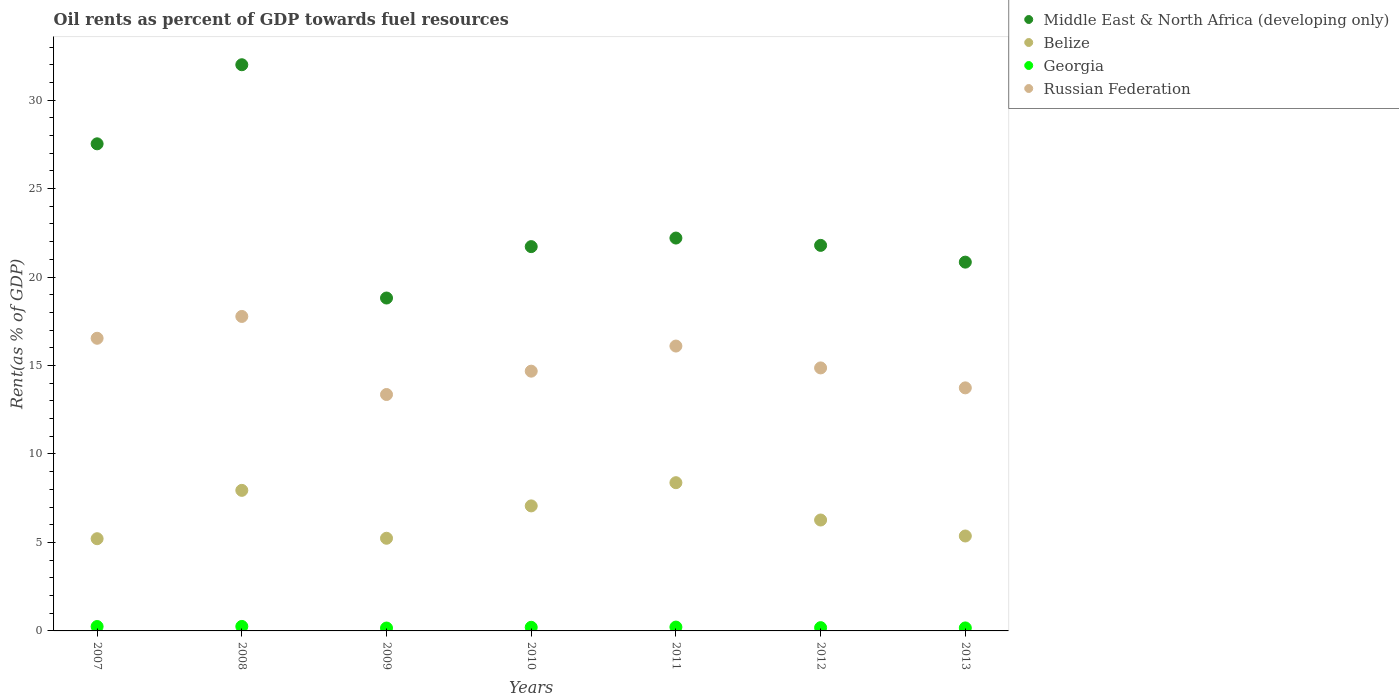How many different coloured dotlines are there?
Your answer should be compact. 4. What is the oil rent in Belize in 2008?
Your answer should be compact. 7.94. Across all years, what is the maximum oil rent in Russian Federation?
Keep it short and to the point. 17.77. Across all years, what is the minimum oil rent in Georgia?
Provide a short and direct response. 0.16. In which year was the oil rent in Middle East & North Africa (developing only) minimum?
Your answer should be compact. 2009. What is the total oil rent in Middle East & North Africa (developing only) in the graph?
Offer a very short reply. 164.91. What is the difference between the oil rent in Belize in 2007 and that in 2009?
Ensure brevity in your answer.  -0.03. What is the difference between the oil rent in Middle East & North Africa (developing only) in 2013 and the oil rent in Russian Federation in 2012?
Your response must be concise. 5.98. What is the average oil rent in Middle East & North Africa (developing only) per year?
Your answer should be very brief. 23.56. In the year 2013, what is the difference between the oil rent in Belize and oil rent in Russian Federation?
Provide a succinct answer. -8.37. What is the ratio of the oil rent in Georgia in 2009 to that in 2011?
Your answer should be compact. 0.75. Is the oil rent in Belize in 2010 less than that in 2012?
Give a very brief answer. No. What is the difference between the highest and the second highest oil rent in Belize?
Provide a succinct answer. 0.43. What is the difference between the highest and the lowest oil rent in Belize?
Your response must be concise. 3.17. Is it the case that in every year, the sum of the oil rent in Georgia and oil rent in Belize  is greater than the sum of oil rent in Middle East & North Africa (developing only) and oil rent in Russian Federation?
Your response must be concise. No. Is it the case that in every year, the sum of the oil rent in Middle East & North Africa (developing only) and oil rent in Russian Federation  is greater than the oil rent in Georgia?
Give a very brief answer. Yes. Is the oil rent in Belize strictly greater than the oil rent in Georgia over the years?
Offer a very short reply. Yes. How many dotlines are there?
Your answer should be compact. 4. How many years are there in the graph?
Keep it short and to the point. 7. What is the difference between two consecutive major ticks on the Y-axis?
Provide a short and direct response. 5. Are the values on the major ticks of Y-axis written in scientific E-notation?
Your answer should be very brief. No. Does the graph contain any zero values?
Provide a succinct answer. No. Does the graph contain grids?
Your answer should be very brief. No. Where does the legend appear in the graph?
Give a very brief answer. Top right. How many legend labels are there?
Give a very brief answer. 4. How are the legend labels stacked?
Your response must be concise. Vertical. What is the title of the graph?
Ensure brevity in your answer.  Oil rents as percent of GDP towards fuel resources. Does "United Kingdom" appear as one of the legend labels in the graph?
Give a very brief answer. No. What is the label or title of the Y-axis?
Keep it short and to the point. Rent(as % of GDP). What is the Rent(as % of GDP) in Middle East & North Africa (developing only) in 2007?
Make the answer very short. 27.53. What is the Rent(as % of GDP) in Belize in 2007?
Your answer should be very brief. 5.21. What is the Rent(as % of GDP) in Georgia in 2007?
Give a very brief answer. 0.25. What is the Rent(as % of GDP) of Russian Federation in 2007?
Provide a short and direct response. 16.54. What is the Rent(as % of GDP) of Middle East & North Africa (developing only) in 2008?
Keep it short and to the point. 32. What is the Rent(as % of GDP) in Belize in 2008?
Offer a terse response. 7.94. What is the Rent(as % of GDP) in Georgia in 2008?
Keep it short and to the point. 0.25. What is the Rent(as % of GDP) in Russian Federation in 2008?
Keep it short and to the point. 17.77. What is the Rent(as % of GDP) in Middle East & North Africa (developing only) in 2009?
Give a very brief answer. 18.82. What is the Rent(as % of GDP) of Belize in 2009?
Offer a terse response. 5.24. What is the Rent(as % of GDP) in Georgia in 2009?
Your response must be concise. 0.16. What is the Rent(as % of GDP) of Russian Federation in 2009?
Keep it short and to the point. 13.36. What is the Rent(as % of GDP) of Middle East & North Africa (developing only) in 2010?
Give a very brief answer. 21.72. What is the Rent(as % of GDP) in Belize in 2010?
Your answer should be very brief. 7.07. What is the Rent(as % of GDP) in Georgia in 2010?
Your answer should be compact. 0.2. What is the Rent(as % of GDP) in Russian Federation in 2010?
Your answer should be very brief. 14.68. What is the Rent(as % of GDP) of Middle East & North Africa (developing only) in 2011?
Ensure brevity in your answer.  22.21. What is the Rent(as % of GDP) in Belize in 2011?
Offer a very short reply. 8.38. What is the Rent(as % of GDP) in Georgia in 2011?
Your response must be concise. 0.22. What is the Rent(as % of GDP) of Russian Federation in 2011?
Provide a short and direct response. 16.1. What is the Rent(as % of GDP) of Middle East & North Africa (developing only) in 2012?
Offer a very short reply. 21.79. What is the Rent(as % of GDP) of Belize in 2012?
Offer a terse response. 6.27. What is the Rent(as % of GDP) of Georgia in 2012?
Your answer should be very brief. 0.18. What is the Rent(as % of GDP) in Russian Federation in 2012?
Offer a very short reply. 14.87. What is the Rent(as % of GDP) of Middle East & North Africa (developing only) in 2013?
Your answer should be compact. 20.84. What is the Rent(as % of GDP) in Belize in 2013?
Your answer should be compact. 5.37. What is the Rent(as % of GDP) of Georgia in 2013?
Offer a very short reply. 0.17. What is the Rent(as % of GDP) in Russian Federation in 2013?
Keep it short and to the point. 13.74. Across all years, what is the maximum Rent(as % of GDP) in Middle East & North Africa (developing only)?
Offer a very short reply. 32. Across all years, what is the maximum Rent(as % of GDP) in Belize?
Your response must be concise. 8.38. Across all years, what is the maximum Rent(as % of GDP) of Georgia?
Offer a terse response. 0.25. Across all years, what is the maximum Rent(as % of GDP) in Russian Federation?
Your answer should be compact. 17.77. Across all years, what is the minimum Rent(as % of GDP) in Middle East & North Africa (developing only)?
Your answer should be compact. 18.82. Across all years, what is the minimum Rent(as % of GDP) in Belize?
Give a very brief answer. 5.21. Across all years, what is the minimum Rent(as % of GDP) in Georgia?
Provide a succinct answer. 0.16. Across all years, what is the minimum Rent(as % of GDP) of Russian Federation?
Provide a succinct answer. 13.36. What is the total Rent(as % of GDP) in Middle East & North Africa (developing only) in the graph?
Offer a very short reply. 164.91. What is the total Rent(as % of GDP) in Belize in the graph?
Offer a terse response. 45.47. What is the total Rent(as % of GDP) in Georgia in the graph?
Make the answer very short. 1.44. What is the total Rent(as % of GDP) of Russian Federation in the graph?
Ensure brevity in your answer.  107.06. What is the difference between the Rent(as % of GDP) in Middle East & North Africa (developing only) in 2007 and that in 2008?
Provide a short and direct response. -4.47. What is the difference between the Rent(as % of GDP) in Belize in 2007 and that in 2008?
Your answer should be compact. -2.73. What is the difference between the Rent(as % of GDP) of Georgia in 2007 and that in 2008?
Provide a short and direct response. -0. What is the difference between the Rent(as % of GDP) in Russian Federation in 2007 and that in 2008?
Give a very brief answer. -1.23. What is the difference between the Rent(as % of GDP) of Middle East & North Africa (developing only) in 2007 and that in 2009?
Your answer should be very brief. 8.72. What is the difference between the Rent(as % of GDP) in Belize in 2007 and that in 2009?
Your answer should be very brief. -0.03. What is the difference between the Rent(as % of GDP) in Georgia in 2007 and that in 2009?
Offer a terse response. 0.09. What is the difference between the Rent(as % of GDP) of Russian Federation in 2007 and that in 2009?
Keep it short and to the point. 3.18. What is the difference between the Rent(as % of GDP) in Middle East & North Africa (developing only) in 2007 and that in 2010?
Your response must be concise. 5.81. What is the difference between the Rent(as % of GDP) of Belize in 2007 and that in 2010?
Ensure brevity in your answer.  -1.85. What is the difference between the Rent(as % of GDP) in Georgia in 2007 and that in 2010?
Provide a succinct answer. 0.04. What is the difference between the Rent(as % of GDP) in Russian Federation in 2007 and that in 2010?
Your answer should be very brief. 1.86. What is the difference between the Rent(as % of GDP) of Middle East & North Africa (developing only) in 2007 and that in 2011?
Keep it short and to the point. 5.33. What is the difference between the Rent(as % of GDP) in Belize in 2007 and that in 2011?
Provide a succinct answer. -3.17. What is the difference between the Rent(as % of GDP) in Georgia in 2007 and that in 2011?
Provide a succinct answer. 0.03. What is the difference between the Rent(as % of GDP) of Russian Federation in 2007 and that in 2011?
Offer a very short reply. 0.44. What is the difference between the Rent(as % of GDP) of Middle East & North Africa (developing only) in 2007 and that in 2012?
Offer a terse response. 5.74. What is the difference between the Rent(as % of GDP) in Belize in 2007 and that in 2012?
Your answer should be compact. -1.06. What is the difference between the Rent(as % of GDP) in Georgia in 2007 and that in 2012?
Give a very brief answer. 0.06. What is the difference between the Rent(as % of GDP) of Russian Federation in 2007 and that in 2012?
Offer a terse response. 1.68. What is the difference between the Rent(as % of GDP) of Middle East & North Africa (developing only) in 2007 and that in 2013?
Your answer should be compact. 6.69. What is the difference between the Rent(as % of GDP) in Belize in 2007 and that in 2013?
Provide a short and direct response. -0.15. What is the difference between the Rent(as % of GDP) in Georgia in 2007 and that in 2013?
Make the answer very short. 0.08. What is the difference between the Rent(as % of GDP) in Russian Federation in 2007 and that in 2013?
Offer a very short reply. 2.8. What is the difference between the Rent(as % of GDP) in Middle East & North Africa (developing only) in 2008 and that in 2009?
Your response must be concise. 13.19. What is the difference between the Rent(as % of GDP) of Belize in 2008 and that in 2009?
Your answer should be very brief. 2.71. What is the difference between the Rent(as % of GDP) in Georgia in 2008 and that in 2009?
Keep it short and to the point. 0.09. What is the difference between the Rent(as % of GDP) of Russian Federation in 2008 and that in 2009?
Keep it short and to the point. 4.41. What is the difference between the Rent(as % of GDP) in Middle East & North Africa (developing only) in 2008 and that in 2010?
Your response must be concise. 10.28. What is the difference between the Rent(as % of GDP) in Belize in 2008 and that in 2010?
Your answer should be very brief. 0.88. What is the difference between the Rent(as % of GDP) of Georgia in 2008 and that in 2010?
Provide a succinct answer. 0.05. What is the difference between the Rent(as % of GDP) of Russian Federation in 2008 and that in 2010?
Provide a short and direct response. 3.09. What is the difference between the Rent(as % of GDP) of Middle East & North Africa (developing only) in 2008 and that in 2011?
Provide a succinct answer. 9.8. What is the difference between the Rent(as % of GDP) of Belize in 2008 and that in 2011?
Make the answer very short. -0.43. What is the difference between the Rent(as % of GDP) of Georgia in 2008 and that in 2011?
Offer a terse response. 0.04. What is the difference between the Rent(as % of GDP) of Russian Federation in 2008 and that in 2011?
Offer a terse response. 1.67. What is the difference between the Rent(as % of GDP) in Middle East & North Africa (developing only) in 2008 and that in 2012?
Provide a succinct answer. 10.21. What is the difference between the Rent(as % of GDP) of Belize in 2008 and that in 2012?
Give a very brief answer. 1.68. What is the difference between the Rent(as % of GDP) of Georgia in 2008 and that in 2012?
Provide a succinct answer. 0.07. What is the difference between the Rent(as % of GDP) of Russian Federation in 2008 and that in 2012?
Offer a very short reply. 2.91. What is the difference between the Rent(as % of GDP) of Middle East & North Africa (developing only) in 2008 and that in 2013?
Offer a terse response. 11.16. What is the difference between the Rent(as % of GDP) of Belize in 2008 and that in 2013?
Your response must be concise. 2.58. What is the difference between the Rent(as % of GDP) of Georgia in 2008 and that in 2013?
Provide a short and direct response. 0.08. What is the difference between the Rent(as % of GDP) of Russian Federation in 2008 and that in 2013?
Provide a succinct answer. 4.04. What is the difference between the Rent(as % of GDP) in Middle East & North Africa (developing only) in 2009 and that in 2010?
Your response must be concise. -2.91. What is the difference between the Rent(as % of GDP) of Belize in 2009 and that in 2010?
Your answer should be very brief. -1.83. What is the difference between the Rent(as % of GDP) of Georgia in 2009 and that in 2010?
Offer a very short reply. -0.04. What is the difference between the Rent(as % of GDP) of Russian Federation in 2009 and that in 2010?
Give a very brief answer. -1.32. What is the difference between the Rent(as % of GDP) of Middle East & North Africa (developing only) in 2009 and that in 2011?
Give a very brief answer. -3.39. What is the difference between the Rent(as % of GDP) in Belize in 2009 and that in 2011?
Provide a succinct answer. -3.14. What is the difference between the Rent(as % of GDP) of Georgia in 2009 and that in 2011?
Keep it short and to the point. -0.05. What is the difference between the Rent(as % of GDP) in Russian Federation in 2009 and that in 2011?
Your answer should be very brief. -2.74. What is the difference between the Rent(as % of GDP) in Middle East & North Africa (developing only) in 2009 and that in 2012?
Give a very brief answer. -2.98. What is the difference between the Rent(as % of GDP) in Belize in 2009 and that in 2012?
Your response must be concise. -1.03. What is the difference between the Rent(as % of GDP) of Georgia in 2009 and that in 2012?
Your answer should be compact. -0.02. What is the difference between the Rent(as % of GDP) of Russian Federation in 2009 and that in 2012?
Make the answer very short. -1.5. What is the difference between the Rent(as % of GDP) in Middle East & North Africa (developing only) in 2009 and that in 2013?
Provide a short and direct response. -2.03. What is the difference between the Rent(as % of GDP) in Belize in 2009 and that in 2013?
Keep it short and to the point. -0.13. What is the difference between the Rent(as % of GDP) of Georgia in 2009 and that in 2013?
Give a very brief answer. -0.01. What is the difference between the Rent(as % of GDP) of Russian Federation in 2009 and that in 2013?
Provide a short and direct response. -0.38. What is the difference between the Rent(as % of GDP) of Middle East & North Africa (developing only) in 2010 and that in 2011?
Offer a terse response. -0.48. What is the difference between the Rent(as % of GDP) of Belize in 2010 and that in 2011?
Your answer should be very brief. -1.31. What is the difference between the Rent(as % of GDP) in Georgia in 2010 and that in 2011?
Your response must be concise. -0.01. What is the difference between the Rent(as % of GDP) of Russian Federation in 2010 and that in 2011?
Your answer should be very brief. -1.42. What is the difference between the Rent(as % of GDP) in Middle East & North Africa (developing only) in 2010 and that in 2012?
Provide a short and direct response. -0.07. What is the difference between the Rent(as % of GDP) in Belize in 2010 and that in 2012?
Keep it short and to the point. 0.8. What is the difference between the Rent(as % of GDP) of Georgia in 2010 and that in 2012?
Provide a short and direct response. 0.02. What is the difference between the Rent(as % of GDP) of Russian Federation in 2010 and that in 2012?
Your response must be concise. -0.18. What is the difference between the Rent(as % of GDP) in Middle East & North Africa (developing only) in 2010 and that in 2013?
Provide a short and direct response. 0.88. What is the difference between the Rent(as % of GDP) in Belize in 2010 and that in 2013?
Give a very brief answer. 1.7. What is the difference between the Rent(as % of GDP) of Georgia in 2010 and that in 2013?
Keep it short and to the point. 0.03. What is the difference between the Rent(as % of GDP) of Russian Federation in 2010 and that in 2013?
Provide a succinct answer. 0.94. What is the difference between the Rent(as % of GDP) in Middle East & North Africa (developing only) in 2011 and that in 2012?
Offer a very short reply. 0.41. What is the difference between the Rent(as % of GDP) of Belize in 2011 and that in 2012?
Make the answer very short. 2.11. What is the difference between the Rent(as % of GDP) in Georgia in 2011 and that in 2012?
Provide a short and direct response. 0.03. What is the difference between the Rent(as % of GDP) of Russian Federation in 2011 and that in 2012?
Your answer should be very brief. 1.24. What is the difference between the Rent(as % of GDP) in Middle East & North Africa (developing only) in 2011 and that in 2013?
Offer a very short reply. 1.36. What is the difference between the Rent(as % of GDP) in Belize in 2011 and that in 2013?
Your answer should be compact. 3.01. What is the difference between the Rent(as % of GDP) in Georgia in 2011 and that in 2013?
Offer a very short reply. 0.05. What is the difference between the Rent(as % of GDP) in Russian Federation in 2011 and that in 2013?
Your answer should be very brief. 2.36. What is the difference between the Rent(as % of GDP) of Middle East & North Africa (developing only) in 2012 and that in 2013?
Offer a terse response. 0.95. What is the difference between the Rent(as % of GDP) in Belize in 2012 and that in 2013?
Your response must be concise. 0.9. What is the difference between the Rent(as % of GDP) of Georgia in 2012 and that in 2013?
Keep it short and to the point. 0.02. What is the difference between the Rent(as % of GDP) in Russian Federation in 2012 and that in 2013?
Give a very brief answer. 1.13. What is the difference between the Rent(as % of GDP) of Middle East & North Africa (developing only) in 2007 and the Rent(as % of GDP) of Belize in 2008?
Offer a very short reply. 19.59. What is the difference between the Rent(as % of GDP) in Middle East & North Africa (developing only) in 2007 and the Rent(as % of GDP) in Georgia in 2008?
Make the answer very short. 27.28. What is the difference between the Rent(as % of GDP) in Middle East & North Africa (developing only) in 2007 and the Rent(as % of GDP) in Russian Federation in 2008?
Your answer should be compact. 9.76. What is the difference between the Rent(as % of GDP) in Belize in 2007 and the Rent(as % of GDP) in Georgia in 2008?
Provide a short and direct response. 4.96. What is the difference between the Rent(as % of GDP) of Belize in 2007 and the Rent(as % of GDP) of Russian Federation in 2008?
Your answer should be compact. -12.56. What is the difference between the Rent(as % of GDP) in Georgia in 2007 and the Rent(as % of GDP) in Russian Federation in 2008?
Your answer should be very brief. -17.53. What is the difference between the Rent(as % of GDP) in Middle East & North Africa (developing only) in 2007 and the Rent(as % of GDP) in Belize in 2009?
Your response must be concise. 22.29. What is the difference between the Rent(as % of GDP) in Middle East & North Africa (developing only) in 2007 and the Rent(as % of GDP) in Georgia in 2009?
Keep it short and to the point. 27.37. What is the difference between the Rent(as % of GDP) in Middle East & North Africa (developing only) in 2007 and the Rent(as % of GDP) in Russian Federation in 2009?
Ensure brevity in your answer.  14.17. What is the difference between the Rent(as % of GDP) in Belize in 2007 and the Rent(as % of GDP) in Georgia in 2009?
Your answer should be compact. 5.05. What is the difference between the Rent(as % of GDP) in Belize in 2007 and the Rent(as % of GDP) in Russian Federation in 2009?
Your answer should be compact. -8.15. What is the difference between the Rent(as % of GDP) of Georgia in 2007 and the Rent(as % of GDP) of Russian Federation in 2009?
Your answer should be very brief. -13.11. What is the difference between the Rent(as % of GDP) of Middle East & North Africa (developing only) in 2007 and the Rent(as % of GDP) of Belize in 2010?
Offer a very short reply. 20.46. What is the difference between the Rent(as % of GDP) in Middle East & North Africa (developing only) in 2007 and the Rent(as % of GDP) in Georgia in 2010?
Your answer should be very brief. 27.33. What is the difference between the Rent(as % of GDP) of Middle East & North Africa (developing only) in 2007 and the Rent(as % of GDP) of Russian Federation in 2010?
Your response must be concise. 12.85. What is the difference between the Rent(as % of GDP) of Belize in 2007 and the Rent(as % of GDP) of Georgia in 2010?
Your answer should be very brief. 5.01. What is the difference between the Rent(as % of GDP) in Belize in 2007 and the Rent(as % of GDP) in Russian Federation in 2010?
Offer a terse response. -9.47. What is the difference between the Rent(as % of GDP) of Georgia in 2007 and the Rent(as % of GDP) of Russian Federation in 2010?
Provide a succinct answer. -14.43. What is the difference between the Rent(as % of GDP) of Middle East & North Africa (developing only) in 2007 and the Rent(as % of GDP) of Belize in 2011?
Your response must be concise. 19.15. What is the difference between the Rent(as % of GDP) in Middle East & North Africa (developing only) in 2007 and the Rent(as % of GDP) in Georgia in 2011?
Offer a terse response. 27.31. What is the difference between the Rent(as % of GDP) in Middle East & North Africa (developing only) in 2007 and the Rent(as % of GDP) in Russian Federation in 2011?
Offer a terse response. 11.43. What is the difference between the Rent(as % of GDP) of Belize in 2007 and the Rent(as % of GDP) of Georgia in 2011?
Provide a short and direct response. 5. What is the difference between the Rent(as % of GDP) in Belize in 2007 and the Rent(as % of GDP) in Russian Federation in 2011?
Offer a terse response. -10.89. What is the difference between the Rent(as % of GDP) of Georgia in 2007 and the Rent(as % of GDP) of Russian Federation in 2011?
Your response must be concise. -15.85. What is the difference between the Rent(as % of GDP) of Middle East & North Africa (developing only) in 2007 and the Rent(as % of GDP) of Belize in 2012?
Your answer should be compact. 21.26. What is the difference between the Rent(as % of GDP) in Middle East & North Africa (developing only) in 2007 and the Rent(as % of GDP) in Georgia in 2012?
Your answer should be very brief. 27.35. What is the difference between the Rent(as % of GDP) in Middle East & North Africa (developing only) in 2007 and the Rent(as % of GDP) in Russian Federation in 2012?
Make the answer very short. 12.67. What is the difference between the Rent(as % of GDP) of Belize in 2007 and the Rent(as % of GDP) of Georgia in 2012?
Offer a very short reply. 5.03. What is the difference between the Rent(as % of GDP) in Belize in 2007 and the Rent(as % of GDP) in Russian Federation in 2012?
Give a very brief answer. -9.65. What is the difference between the Rent(as % of GDP) of Georgia in 2007 and the Rent(as % of GDP) of Russian Federation in 2012?
Provide a succinct answer. -14.62. What is the difference between the Rent(as % of GDP) of Middle East & North Africa (developing only) in 2007 and the Rent(as % of GDP) of Belize in 2013?
Make the answer very short. 22.17. What is the difference between the Rent(as % of GDP) of Middle East & North Africa (developing only) in 2007 and the Rent(as % of GDP) of Georgia in 2013?
Offer a terse response. 27.36. What is the difference between the Rent(as % of GDP) in Middle East & North Africa (developing only) in 2007 and the Rent(as % of GDP) in Russian Federation in 2013?
Your response must be concise. 13.79. What is the difference between the Rent(as % of GDP) in Belize in 2007 and the Rent(as % of GDP) in Georgia in 2013?
Keep it short and to the point. 5.04. What is the difference between the Rent(as % of GDP) in Belize in 2007 and the Rent(as % of GDP) in Russian Federation in 2013?
Give a very brief answer. -8.53. What is the difference between the Rent(as % of GDP) in Georgia in 2007 and the Rent(as % of GDP) in Russian Federation in 2013?
Your answer should be very brief. -13.49. What is the difference between the Rent(as % of GDP) of Middle East & North Africa (developing only) in 2008 and the Rent(as % of GDP) of Belize in 2009?
Ensure brevity in your answer.  26.76. What is the difference between the Rent(as % of GDP) in Middle East & North Africa (developing only) in 2008 and the Rent(as % of GDP) in Georgia in 2009?
Your answer should be compact. 31.84. What is the difference between the Rent(as % of GDP) in Middle East & North Africa (developing only) in 2008 and the Rent(as % of GDP) in Russian Federation in 2009?
Your response must be concise. 18.64. What is the difference between the Rent(as % of GDP) of Belize in 2008 and the Rent(as % of GDP) of Georgia in 2009?
Provide a short and direct response. 7.78. What is the difference between the Rent(as % of GDP) in Belize in 2008 and the Rent(as % of GDP) in Russian Federation in 2009?
Make the answer very short. -5.42. What is the difference between the Rent(as % of GDP) of Georgia in 2008 and the Rent(as % of GDP) of Russian Federation in 2009?
Your answer should be compact. -13.11. What is the difference between the Rent(as % of GDP) of Middle East & North Africa (developing only) in 2008 and the Rent(as % of GDP) of Belize in 2010?
Provide a short and direct response. 24.93. What is the difference between the Rent(as % of GDP) in Middle East & North Africa (developing only) in 2008 and the Rent(as % of GDP) in Georgia in 2010?
Ensure brevity in your answer.  31.8. What is the difference between the Rent(as % of GDP) in Middle East & North Africa (developing only) in 2008 and the Rent(as % of GDP) in Russian Federation in 2010?
Your response must be concise. 17.32. What is the difference between the Rent(as % of GDP) of Belize in 2008 and the Rent(as % of GDP) of Georgia in 2010?
Offer a very short reply. 7.74. What is the difference between the Rent(as % of GDP) of Belize in 2008 and the Rent(as % of GDP) of Russian Federation in 2010?
Make the answer very short. -6.74. What is the difference between the Rent(as % of GDP) in Georgia in 2008 and the Rent(as % of GDP) in Russian Federation in 2010?
Make the answer very short. -14.43. What is the difference between the Rent(as % of GDP) in Middle East & North Africa (developing only) in 2008 and the Rent(as % of GDP) in Belize in 2011?
Your answer should be compact. 23.62. What is the difference between the Rent(as % of GDP) of Middle East & North Africa (developing only) in 2008 and the Rent(as % of GDP) of Georgia in 2011?
Ensure brevity in your answer.  31.78. What is the difference between the Rent(as % of GDP) of Middle East & North Africa (developing only) in 2008 and the Rent(as % of GDP) of Russian Federation in 2011?
Your response must be concise. 15.9. What is the difference between the Rent(as % of GDP) in Belize in 2008 and the Rent(as % of GDP) in Georgia in 2011?
Ensure brevity in your answer.  7.73. What is the difference between the Rent(as % of GDP) of Belize in 2008 and the Rent(as % of GDP) of Russian Federation in 2011?
Ensure brevity in your answer.  -8.16. What is the difference between the Rent(as % of GDP) of Georgia in 2008 and the Rent(as % of GDP) of Russian Federation in 2011?
Keep it short and to the point. -15.85. What is the difference between the Rent(as % of GDP) in Middle East & North Africa (developing only) in 2008 and the Rent(as % of GDP) in Belize in 2012?
Your answer should be compact. 25.73. What is the difference between the Rent(as % of GDP) in Middle East & North Africa (developing only) in 2008 and the Rent(as % of GDP) in Georgia in 2012?
Keep it short and to the point. 31.82. What is the difference between the Rent(as % of GDP) of Middle East & North Africa (developing only) in 2008 and the Rent(as % of GDP) of Russian Federation in 2012?
Make the answer very short. 17.14. What is the difference between the Rent(as % of GDP) of Belize in 2008 and the Rent(as % of GDP) of Georgia in 2012?
Offer a very short reply. 7.76. What is the difference between the Rent(as % of GDP) in Belize in 2008 and the Rent(as % of GDP) in Russian Federation in 2012?
Provide a short and direct response. -6.92. What is the difference between the Rent(as % of GDP) of Georgia in 2008 and the Rent(as % of GDP) of Russian Federation in 2012?
Your answer should be very brief. -14.61. What is the difference between the Rent(as % of GDP) in Middle East & North Africa (developing only) in 2008 and the Rent(as % of GDP) in Belize in 2013?
Your answer should be compact. 26.64. What is the difference between the Rent(as % of GDP) in Middle East & North Africa (developing only) in 2008 and the Rent(as % of GDP) in Georgia in 2013?
Make the answer very short. 31.83. What is the difference between the Rent(as % of GDP) in Middle East & North Africa (developing only) in 2008 and the Rent(as % of GDP) in Russian Federation in 2013?
Give a very brief answer. 18.26. What is the difference between the Rent(as % of GDP) of Belize in 2008 and the Rent(as % of GDP) of Georgia in 2013?
Give a very brief answer. 7.78. What is the difference between the Rent(as % of GDP) in Belize in 2008 and the Rent(as % of GDP) in Russian Federation in 2013?
Keep it short and to the point. -5.79. What is the difference between the Rent(as % of GDP) of Georgia in 2008 and the Rent(as % of GDP) of Russian Federation in 2013?
Ensure brevity in your answer.  -13.48. What is the difference between the Rent(as % of GDP) of Middle East & North Africa (developing only) in 2009 and the Rent(as % of GDP) of Belize in 2010?
Make the answer very short. 11.75. What is the difference between the Rent(as % of GDP) in Middle East & North Africa (developing only) in 2009 and the Rent(as % of GDP) in Georgia in 2010?
Provide a succinct answer. 18.61. What is the difference between the Rent(as % of GDP) of Middle East & North Africa (developing only) in 2009 and the Rent(as % of GDP) of Russian Federation in 2010?
Your response must be concise. 4.13. What is the difference between the Rent(as % of GDP) in Belize in 2009 and the Rent(as % of GDP) in Georgia in 2010?
Your answer should be very brief. 5.03. What is the difference between the Rent(as % of GDP) of Belize in 2009 and the Rent(as % of GDP) of Russian Federation in 2010?
Ensure brevity in your answer.  -9.44. What is the difference between the Rent(as % of GDP) in Georgia in 2009 and the Rent(as % of GDP) in Russian Federation in 2010?
Your answer should be very brief. -14.52. What is the difference between the Rent(as % of GDP) of Middle East & North Africa (developing only) in 2009 and the Rent(as % of GDP) of Belize in 2011?
Give a very brief answer. 10.44. What is the difference between the Rent(as % of GDP) in Middle East & North Africa (developing only) in 2009 and the Rent(as % of GDP) in Georgia in 2011?
Provide a succinct answer. 18.6. What is the difference between the Rent(as % of GDP) of Middle East & North Africa (developing only) in 2009 and the Rent(as % of GDP) of Russian Federation in 2011?
Give a very brief answer. 2.71. What is the difference between the Rent(as % of GDP) in Belize in 2009 and the Rent(as % of GDP) in Georgia in 2011?
Provide a succinct answer. 5.02. What is the difference between the Rent(as % of GDP) of Belize in 2009 and the Rent(as % of GDP) of Russian Federation in 2011?
Keep it short and to the point. -10.86. What is the difference between the Rent(as % of GDP) of Georgia in 2009 and the Rent(as % of GDP) of Russian Federation in 2011?
Keep it short and to the point. -15.94. What is the difference between the Rent(as % of GDP) in Middle East & North Africa (developing only) in 2009 and the Rent(as % of GDP) in Belize in 2012?
Your response must be concise. 12.55. What is the difference between the Rent(as % of GDP) in Middle East & North Africa (developing only) in 2009 and the Rent(as % of GDP) in Georgia in 2012?
Provide a short and direct response. 18.63. What is the difference between the Rent(as % of GDP) in Middle East & North Africa (developing only) in 2009 and the Rent(as % of GDP) in Russian Federation in 2012?
Provide a short and direct response. 3.95. What is the difference between the Rent(as % of GDP) of Belize in 2009 and the Rent(as % of GDP) of Georgia in 2012?
Make the answer very short. 5.05. What is the difference between the Rent(as % of GDP) in Belize in 2009 and the Rent(as % of GDP) in Russian Federation in 2012?
Your answer should be very brief. -9.63. What is the difference between the Rent(as % of GDP) in Georgia in 2009 and the Rent(as % of GDP) in Russian Federation in 2012?
Your answer should be very brief. -14.7. What is the difference between the Rent(as % of GDP) in Middle East & North Africa (developing only) in 2009 and the Rent(as % of GDP) in Belize in 2013?
Ensure brevity in your answer.  13.45. What is the difference between the Rent(as % of GDP) of Middle East & North Africa (developing only) in 2009 and the Rent(as % of GDP) of Georgia in 2013?
Provide a short and direct response. 18.65. What is the difference between the Rent(as % of GDP) in Middle East & North Africa (developing only) in 2009 and the Rent(as % of GDP) in Russian Federation in 2013?
Your answer should be very brief. 5.08. What is the difference between the Rent(as % of GDP) in Belize in 2009 and the Rent(as % of GDP) in Georgia in 2013?
Make the answer very short. 5.07. What is the difference between the Rent(as % of GDP) of Belize in 2009 and the Rent(as % of GDP) of Russian Federation in 2013?
Offer a very short reply. -8.5. What is the difference between the Rent(as % of GDP) of Georgia in 2009 and the Rent(as % of GDP) of Russian Federation in 2013?
Ensure brevity in your answer.  -13.57. What is the difference between the Rent(as % of GDP) of Middle East & North Africa (developing only) in 2010 and the Rent(as % of GDP) of Belize in 2011?
Provide a short and direct response. 13.34. What is the difference between the Rent(as % of GDP) in Middle East & North Africa (developing only) in 2010 and the Rent(as % of GDP) in Georgia in 2011?
Ensure brevity in your answer.  21.5. What is the difference between the Rent(as % of GDP) in Middle East & North Africa (developing only) in 2010 and the Rent(as % of GDP) in Russian Federation in 2011?
Keep it short and to the point. 5.62. What is the difference between the Rent(as % of GDP) in Belize in 2010 and the Rent(as % of GDP) in Georgia in 2011?
Ensure brevity in your answer.  6.85. What is the difference between the Rent(as % of GDP) in Belize in 2010 and the Rent(as % of GDP) in Russian Federation in 2011?
Give a very brief answer. -9.03. What is the difference between the Rent(as % of GDP) in Georgia in 2010 and the Rent(as % of GDP) in Russian Federation in 2011?
Your answer should be very brief. -15.9. What is the difference between the Rent(as % of GDP) in Middle East & North Africa (developing only) in 2010 and the Rent(as % of GDP) in Belize in 2012?
Make the answer very short. 15.45. What is the difference between the Rent(as % of GDP) in Middle East & North Africa (developing only) in 2010 and the Rent(as % of GDP) in Georgia in 2012?
Your answer should be very brief. 21.54. What is the difference between the Rent(as % of GDP) in Middle East & North Africa (developing only) in 2010 and the Rent(as % of GDP) in Russian Federation in 2012?
Your answer should be compact. 6.86. What is the difference between the Rent(as % of GDP) in Belize in 2010 and the Rent(as % of GDP) in Georgia in 2012?
Your answer should be very brief. 6.88. What is the difference between the Rent(as % of GDP) of Belize in 2010 and the Rent(as % of GDP) of Russian Federation in 2012?
Provide a short and direct response. -7.8. What is the difference between the Rent(as % of GDP) of Georgia in 2010 and the Rent(as % of GDP) of Russian Federation in 2012?
Provide a short and direct response. -14.66. What is the difference between the Rent(as % of GDP) in Middle East & North Africa (developing only) in 2010 and the Rent(as % of GDP) in Belize in 2013?
Provide a short and direct response. 16.36. What is the difference between the Rent(as % of GDP) of Middle East & North Africa (developing only) in 2010 and the Rent(as % of GDP) of Georgia in 2013?
Your answer should be compact. 21.55. What is the difference between the Rent(as % of GDP) of Middle East & North Africa (developing only) in 2010 and the Rent(as % of GDP) of Russian Federation in 2013?
Ensure brevity in your answer.  7.98. What is the difference between the Rent(as % of GDP) of Belize in 2010 and the Rent(as % of GDP) of Georgia in 2013?
Provide a succinct answer. 6.9. What is the difference between the Rent(as % of GDP) of Belize in 2010 and the Rent(as % of GDP) of Russian Federation in 2013?
Provide a succinct answer. -6.67. What is the difference between the Rent(as % of GDP) in Georgia in 2010 and the Rent(as % of GDP) in Russian Federation in 2013?
Your answer should be very brief. -13.53. What is the difference between the Rent(as % of GDP) in Middle East & North Africa (developing only) in 2011 and the Rent(as % of GDP) in Belize in 2012?
Keep it short and to the point. 15.94. What is the difference between the Rent(as % of GDP) of Middle East & North Africa (developing only) in 2011 and the Rent(as % of GDP) of Georgia in 2012?
Keep it short and to the point. 22.02. What is the difference between the Rent(as % of GDP) in Middle East & North Africa (developing only) in 2011 and the Rent(as % of GDP) in Russian Federation in 2012?
Ensure brevity in your answer.  7.34. What is the difference between the Rent(as % of GDP) in Belize in 2011 and the Rent(as % of GDP) in Georgia in 2012?
Give a very brief answer. 8.19. What is the difference between the Rent(as % of GDP) of Belize in 2011 and the Rent(as % of GDP) of Russian Federation in 2012?
Offer a very short reply. -6.49. What is the difference between the Rent(as % of GDP) in Georgia in 2011 and the Rent(as % of GDP) in Russian Federation in 2012?
Your response must be concise. -14.65. What is the difference between the Rent(as % of GDP) of Middle East & North Africa (developing only) in 2011 and the Rent(as % of GDP) of Belize in 2013?
Your response must be concise. 16.84. What is the difference between the Rent(as % of GDP) in Middle East & North Africa (developing only) in 2011 and the Rent(as % of GDP) in Georgia in 2013?
Your answer should be very brief. 22.04. What is the difference between the Rent(as % of GDP) in Middle East & North Africa (developing only) in 2011 and the Rent(as % of GDP) in Russian Federation in 2013?
Provide a short and direct response. 8.47. What is the difference between the Rent(as % of GDP) of Belize in 2011 and the Rent(as % of GDP) of Georgia in 2013?
Ensure brevity in your answer.  8.21. What is the difference between the Rent(as % of GDP) of Belize in 2011 and the Rent(as % of GDP) of Russian Federation in 2013?
Give a very brief answer. -5.36. What is the difference between the Rent(as % of GDP) of Georgia in 2011 and the Rent(as % of GDP) of Russian Federation in 2013?
Give a very brief answer. -13.52. What is the difference between the Rent(as % of GDP) of Middle East & North Africa (developing only) in 2012 and the Rent(as % of GDP) of Belize in 2013?
Provide a short and direct response. 16.43. What is the difference between the Rent(as % of GDP) in Middle East & North Africa (developing only) in 2012 and the Rent(as % of GDP) in Georgia in 2013?
Offer a very short reply. 21.62. What is the difference between the Rent(as % of GDP) in Middle East & North Africa (developing only) in 2012 and the Rent(as % of GDP) in Russian Federation in 2013?
Provide a short and direct response. 8.05. What is the difference between the Rent(as % of GDP) of Belize in 2012 and the Rent(as % of GDP) of Georgia in 2013?
Your response must be concise. 6.1. What is the difference between the Rent(as % of GDP) of Belize in 2012 and the Rent(as % of GDP) of Russian Federation in 2013?
Ensure brevity in your answer.  -7.47. What is the difference between the Rent(as % of GDP) of Georgia in 2012 and the Rent(as % of GDP) of Russian Federation in 2013?
Keep it short and to the point. -13.55. What is the average Rent(as % of GDP) in Middle East & North Africa (developing only) per year?
Your response must be concise. 23.56. What is the average Rent(as % of GDP) of Belize per year?
Your answer should be compact. 6.5. What is the average Rent(as % of GDP) of Georgia per year?
Ensure brevity in your answer.  0.21. What is the average Rent(as % of GDP) in Russian Federation per year?
Provide a short and direct response. 15.29. In the year 2007, what is the difference between the Rent(as % of GDP) of Middle East & North Africa (developing only) and Rent(as % of GDP) of Belize?
Provide a short and direct response. 22.32. In the year 2007, what is the difference between the Rent(as % of GDP) of Middle East & North Africa (developing only) and Rent(as % of GDP) of Georgia?
Give a very brief answer. 27.28. In the year 2007, what is the difference between the Rent(as % of GDP) of Middle East & North Africa (developing only) and Rent(as % of GDP) of Russian Federation?
Your response must be concise. 10.99. In the year 2007, what is the difference between the Rent(as % of GDP) of Belize and Rent(as % of GDP) of Georgia?
Keep it short and to the point. 4.96. In the year 2007, what is the difference between the Rent(as % of GDP) of Belize and Rent(as % of GDP) of Russian Federation?
Ensure brevity in your answer.  -11.33. In the year 2007, what is the difference between the Rent(as % of GDP) of Georgia and Rent(as % of GDP) of Russian Federation?
Ensure brevity in your answer.  -16.29. In the year 2008, what is the difference between the Rent(as % of GDP) in Middle East & North Africa (developing only) and Rent(as % of GDP) in Belize?
Keep it short and to the point. 24.06. In the year 2008, what is the difference between the Rent(as % of GDP) of Middle East & North Africa (developing only) and Rent(as % of GDP) of Georgia?
Offer a very short reply. 31.75. In the year 2008, what is the difference between the Rent(as % of GDP) of Middle East & North Africa (developing only) and Rent(as % of GDP) of Russian Federation?
Your answer should be compact. 14.23. In the year 2008, what is the difference between the Rent(as % of GDP) in Belize and Rent(as % of GDP) in Georgia?
Provide a succinct answer. 7.69. In the year 2008, what is the difference between the Rent(as % of GDP) in Belize and Rent(as % of GDP) in Russian Federation?
Ensure brevity in your answer.  -9.83. In the year 2008, what is the difference between the Rent(as % of GDP) of Georgia and Rent(as % of GDP) of Russian Federation?
Ensure brevity in your answer.  -17.52. In the year 2009, what is the difference between the Rent(as % of GDP) in Middle East & North Africa (developing only) and Rent(as % of GDP) in Belize?
Offer a terse response. 13.58. In the year 2009, what is the difference between the Rent(as % of GDP) in Middle East & North Africa (developing only) and Rent(as % of GDP) in Georgia?
Keep it short and to the point. 18.65. In the year 2009, what is the difference between the Rent(as % of GDP) of Middle East & North Africa (developing only) and Rent(as % of GDP) of Russian Federation?
Keep it short and to the point. 5.45. In the year 2009, what is the difference between the Rent(as % of GDP) in Belize and Rent(as % of GDP) in Georgia?
Ensure brevity in your answer.  5.07. In the year 2009, what is the difference between the Rent(as % of GDP) of Belize and Rent(as % of GDP) of Russian Federation?
Offer a terse response. -8.12. In the year 2009, what is the difference between the Rent(as % of GDP) in Georgia and Rent(as % of GDP) in Russian Federation?
Offer a very short reply. -13.2. In the year 2010, what is the difference between the Rent(as % of GDP) of Middle East & North Africa (developing only) and Rent(as % of GDP) of Belize?
Ensure brevity in your answer.  14.65. In the year 2010, what is the difference between the Rent(as % of GDP) in Middle East & North Africa (developing only) and Rent(as % of GDP) in Georgia?
Make the answer very short. 21.52. In the year 2010, what is the difference between the Rent(as % of GDP) in Middle East & North Africa (developing only) and Rent(as % of GDP) in Russian Federation?
Offer a very short reply. 7.04. In the year 2010, what is the difference between the Rent(as % of GDP) of Belize and Rent(as % of GDP) of Georgia?
Your answer should be compact. 6.86. In the year 2010, what is the difference between the Rent(as % of GDP) of Belize and Rent(as % of GDP) of Russian Federation?
Give a very brief answer. -7.62. In the year 2010, what is the difference between the Rent(as % of GDP) of Georgia and Rent(as % of GDP) of Russian Federation?
Your answer should be very brief. -14.48. In the year 2011, what is the difference between the Rent(as % of GDP) in Middle East & North Africa (developing only) and Rent(as % of GDP) in Belize?
Keep it short and to the point. 13.83. In the year 2011, what is the difference between the Rent(as % of GDP) in Middle East & North Africa (developing only) and Rent(as % of GDP) in Georgia?
Keep it short and to the point. 21.99. In the year 2011, what is the difference between the Rent(as % of GDP) of Middle East & North Africa (developing only) and Rent(as % of GDP) of Russian Federation?
Provide a short and direct response. 6.1. In the year 2011, what is the difference between the Rent(as % of GDP) of Belize and Rent(as % of GDP) of Georgia?
Your answer should be compact. 8.16. In the year 2011, what is the difference between the Rent(as % of GDP) of Belize and Rent(as % of GDP) of Russian Federation?
Provide a short and direct response. -7.72. In the year 2011, what is the difference between the Rent(as % of GDP) in Georgia and Rent(as % of GDP) in Russian Federation?
Provide a succinct answer. -15.88. In the year 2012, what is the difference between the Rent(as % of GDP) of Middle East & North Africa (developing only) and Rent(as % of GDP) of Belize?
Make the answer very short. 15.52. In the year 2012, what is the difference between the Rent(as % of GDP) of Middle East & North Africa (developing only) and Rent(as % of GDP) of Georgia?
Your answer should be compact. 21.61. In the year 2012, what is the difference between the Rent(as % of GDP) of Middle East & North Africa (developing only) and Rent(as % of GDP) of Russian Federation?
Offer a terse response. 6.93. In the year 2012, what is the difference between the Rent(as % of GDP) in Belize and Rent(as % of GDP) in Georgia?
Keep it short and to the point. 6.08. In the year 2012, what is the difference between the Rent(as % of GDP) in Belize and Rent(as % of GDP) in Russian Federation?
Offer a very short reply. -8.6. In the year 2012, what is the difference between the Rent(as % of GDP) of Georgia and Rent(as % of GDP) of Russian Federation?
Keep it short and to the point. -14.68. In the year 2013, what is the difference between the Rent(as % of GDP) of Middle East & North Africa (developing only) and Rent(as % of GDP) of Belize?
Your answer should be very brief. 15.48. In the year 2013, what is the difference between the Rent(as % of GDP) of Middle East & North Africa (developing only) and Rent(as % of GDP) of Georgia?
Your answer should be compact. 20.68. In the year 2013, what is the difference between the Rent(as % of GDP) in Middle East & North Africa (developing only) and Rent(as % of GDP) in Russian Federation?
Your answer should be very brief. 7.11. In the year 2013, what is the difference between the Rent(as % of GDP) in Belize and Rent(as % of GDP) in Georgia?
Offer a terse response. 5.2. In the year 2013, what is the difference between the Rent(as % of GDP) of Belize and Rent(as % of GDP) of Russian Federation?
Offer a very short reply. -8.37. In the year 2013, what is the difference between the Rent(as % of GDP) of Georgia and Rent(as % of GDP) of Russian Federation?
Give a very brief answer. -13.57. What is the ratio of the Rent(as % of GDP) in Middle East & North Africa (developing only) in 2007 to that in 2008?
Offer a terse response. 0.86. What is the ratio of the Rent(as % of GDP) in Belize in 2007 to that in 2008?
Your answer should be compact. 0.66. What is the ratio of the Rent(as % of GDP) in Georgia in 2007 to that in 2008?
Offer a very short reply. 0.98. What is the ratio of the Rent(as % of GDP) in Russian Federation in 2007 to that in 2008?
Make the answer very short. 0.93. What is the ratio of the Rent(as % of GDP) in Middle East & North Africa (developing only) in 2007 to that in 2009?
Your answer should be compact. 1.46. What is the ratio of the Rent(as % of GDP) of Georgia in 2007 to that in 2009?
Offer a very short reply. 1.52. What is the ratio of the Rent(as % of GDP) in Russian Federation in 2007 to that in 2009?
Keep it short and to the point. 1.24. What is the ratio of the Rent(as % of GDP) of Middle East & North Africa (developing only) in 2007 to that in 2010?
Provide a short and direct response. 1.27. What is the ratio of the Rent(as % of GDP) in Belize in 2007 to that in 2010?
Keep it short and to the point. 0.74. What is the ratio of the Rent(as % of GDP) in Georgia in 2007 to that in 2010?
Provide a short and direct response. 1.22. What is the ratio of the Rent(as % of GDP) of Russian Federation in 2007 to that in 2010?
Make the answer very short. 1.13. What is the ratio of the Rent(as % of GDP) in Middle East & North Africa (developing only) in 2007 to that in 2011?
Provide a short and direct response. 1.24. What is the ratio of the Rent(as % of GDP) in Belize in 2007 to that in 2011?
Provide a short and direct response. 0.62. What is the ratio of the Rent(as % of GDP) in Georgia in 2007 to that in 2011?
Give a very brief answer. 1.15. What is the ratio of the Rent(as % of GDP) in Russian Federation in 2007 to that in 2011?
Offer a terse response. 1.03. What is the ratio of the Rent(as % of GDP) of Middle East & North Africa (developing only) in 2007 to that in 2012?
Ensure brevity in your answer.  1.26. What is the ratio of the Rent(as % of GDP) of Belize in 2007 to that in 2012?
Keep it short and to the point. 0.83. What is the ratio of the Rent(as % of GDP) of Georgia in 2007 to that in 2012?
Offer a very short reply. 1.35. What is the ratio of the Rent(as % of GDP) of Russian Federation in 2007 to that in 2012?
Your answer should be very brief. 1.11. What is the ratio of the Rent(as % of GDP) of Middle East & North Africa (developing only) in 2007 to that in 2013?
Keep it short and to the point. 1.32. What is the ratio of the Rent(as % of GDP) of Belize in 2007 to that in 2013?
Provide a short and direct response. 0.97. What is the ratio of the Rent(as % of GDP) of Georgia in 2007 to that in 2013?
Offer a terse response. 1.47. What is the ratio of the Rent(as % of GDP) of Russian Federation in 2007 to that in 2013?
Keep it short and to the point. 1.2. What is the ratio of the Rent(as % of GDP) of Middle East & North Africa (developing only) in 2008 to that in 2009?
Offer a terse response. 1.7. What is the ratio of the Rent(as % of GDP) of Belize in 2008 to that in 2009?
Provide a short and direct response. 1.52. What is the ratio of the Rent(as % of GDP) in Georgia in 2008 to that in 2009?
Offer a terse response. 1.55. What is the ratio of the Rent(as % of GDP) of Russian Federation in 2008 to that in 2009?
Offer a terse response. 1.33. What is the ratio of the Rent(as % of GDP) of Middle East & North Africa (developing only) in 2008 to that in 2010?
Give a very brief answer. 1.47. What is the ratio of the Rent(as % of GDP) of Belize in 2008 to that in 2010?
Provide a short and direct response. 1.12. What is the ratio of the Rent(as % of GDP) in Georgia in 2008 to that in 2010?
Ensure brevity in your answer.  1.24. What is the ratio of the Rent(as % of GDP) in Russian Federation in 2008 to that in 2010?
Your answer should be very brief. 1.21. What is the ratio of the Rent(as % of GDP) of Middle East & North Africa (developing only) in 2008 to that in 2011?
Your answer should be very brief. 1.44. What is the ratio of the Rent(as % of GDP) in Belize in 2008 to that in 2011?
Offer a terse response. 0.95. What is the ratio of the Rent(as % of GDP) in Georgia in 2008 to that in 2011?
Your response must be concise. 1.17. What is the ratio of the Rent(as % of GDP) in Russian Federation in 2008 to that in 2011?
Your answer should be compact. 1.1. What is the ratio of the Rent(as % of GDP) in Middle East & North Africa (developing only) in 2008 to that in 2012?
Your response must be concise. 1.47. What is the ratio of the Rent(as % of GDP) in Belize in 2008 to that in 2012?
Your answer should be very brief. 1.27. What is the ratio of the Rent(as % of GDP) of Georgia in 2008 to that in 2012?
Your answer should be very brief. 1.37. What is the ratio of the Rent(as % of GDP) of Russian Federation in 2008 to that in 2012?
Keep it short and to the point. 1.2. What is the ratio of the Rent(as % of GDP) in Middle East & North Africa (developing only) in 2008 to that in 2013?
Your answer should be very brief. 1.54. What is the ratio of the Rent(as % of GDP) in Belize in 2008 to that in 2013?
Provide a succinct answer. 1.48. What is the ratio of the Rent(as % of GDP) in Georgia in 2008 to that in 2013?
Provide a succinct answer. 1.5. What is the ratio of the Rent(as % of GDP) in Russian Federation in 2008 to that in 2013?
Your answer should be very brief. 1.29. What is the ratio of the Rent(as % of GDP) of Middle East & North Africa (developing only) in 2009 to that in 2010?
Offer a terse response. 0.87. What is the ratio of the Rent(as % of GDP) in Belize in 2009 to that in 2010?
Offer a terse response. 0.74. What is the ratio of the Rent(as % of GDP) in Georgia in 2009 to that in 2010?
Provide a short and direct response. 0.8. What is the ratio of the Rent(as % of GDP) in Russian Federation in 2009 to that in 2010?
Give a very brief answer. 0.91. What is the ratio of the Rent(as % of GDP) of Middle East & North Africa (developing only) in 2009 to that in 2011?
Make the answer very short. 0.85. What is the ratio of the Rent(as % of GDP) of Belize in 2009 to that in 2011?
Keep it short and to the point. 0.63. What is the ratio of the Rent(as % of GDP) of Georgia in 2009 to that in 2011?
Offer a very short reply. 0.75. What is the ratio of the Rent(as % of GDP) in Russian Federation in 2009 to that in 2011?
Provide a short and direct response. 0.83. What is the ratio of the Rent(as % of GDP) in Middle East & North Africa (developing only) in 2009 to that in 2012?
Make the answer very short. 0.86. What is the ratio of the Rent(as % of GDP) of Belize in 2009 to that in 2012?
Ensure brevity in your answer.  0.84. What is the ratio of the Rent(as % of GDP) of Georgia in 2009 to that in 2012?
Provide a succinct answer. 0.88. What is the ratio of the Rent(as % of GDP) of Russian Federation in 2009 to that in 2012?
Provide a succinct answer. 0.9. What is the ratio of the Rent(as % of GDP) in Middle East & North Africa (developing only) in 2009 to that in 2013?
Provide a succinct answer. 0.9. What is the ratio of the Rent(as % of GDP) in Belize in 2009 to that in 2013?
Keep it short and to the point. 0.98. What is the ratio of the Rent(as % of GDP) of Georgia in 2009 to that in 2013?
Your answer should be very brief. 0.96. What is the ratio of the Rent(as % of GDP) in Russian Federation in 2009 to that in 2013?
Your answer should be compact. 0.97. What is the ratio of the Rent(as % of GDP) in Middle East & North Africa (developing only) in 2010 to that in 2011?
Provide a short and direct response. 0.98. What is the ratio of the Rent(as % of GDP) in Belize in 2010 to that in 2011?
Your answer should be very brief. 0.84. What is the ratio of the Rent(as % of GDP) of Georgia in 2010 to that in 2011?
Provide a short and direct response. 0.94. What is the ratio of the Rent(as % of GDP) of Russian Federation in 2010 to that in 2011?
Provide a short and direct response. 0.91. What is the ratio of the Rent(as % of GDP) of Belize in 2010 to that in 2012?
Provide a succinct answer. 1.13. What is the ratio of the Rent(as % of GDP) in Georgia in 2010 to that in 2012?
Offer a very short reply. 1.11. What is the ratio of the Rent(as % of GDP) in Russian Federation in 2010 to that in 2012?
Offer a terse response. 0.99. What is the ratio of the Rent(as % of GDP) of Middle East & North Africa (developing only) in 2010 to that in 2013?
Provide a succinct answer. 1.04. What is the ratio of the Rent(as % of GDP) of Belize in 2010 to that in 2013?
Your answer should be very brief. 1.32. What is the ratio of the Rent(as % of GDP) in Georgia in 2010 to that in 2013?
Keep it short and to the point. 1.21. What is the ratio of the Rent(as % of GDP) in Russian Federation in 2010 to that in 2013?
Offer a very short reply. 1.07. What is the ratio of the Rent(as % of GDP) of Belize in 2011 to that in 2012?
Your response must be concise. 1.34. What is the ratio of the Rent(as % of GDP) in Georgia in 2011 to that in 2012?
Provide a short and direct response. 1.17. What is the ratio of the Rent(as % of GDP) in Russian Federation in 2011 to that in 2012?
Your response must be concise. 1.08. What is the ratio of the Rent(as % of GDP) of Middle East & North Africa (developing only) in 2011 to that in 2013?
Your answer should be compact. 1.07. What is the ratio of the Rent(as % of GDP) of Belize in 2011 to that in 2013?
Keep it short and to the point. 1.56. What is the ratio of the Rent(as % of GDP) of Georgia in 2011 to that in 2013?
Your response must be concise. 1.28. What is the ratio of the Rent(as % of GDP) in Russian Federation in 2011 to that in 2013?
Provide a succinct answer. 1.17. What is the ratio of the Rent(as % of GDP) of Middle East & North Africa (developing only) in 2012 to that in 2013?
Offer a very short reply. 1.05. What is the ratio of the Rent(as % of GDP) of Belize in 2012 to that in 2013?
Offer a very short reply. 1.17. What is the ratio of the Rent(as % of GDP) in Georgia in 2012 to that in 2013?
Provide a succinct answer. 1.09. What is the ratio of the Rent(as % of GDP) of Russian Federation in 2012 to that in 2013?
Your answer should be compact. 1.08. What is the difference between the highest and the second highest Rent(as % of GDP) of Middle East & North Africa (developing only)?
Ensure brevity in your answer.  4.47. What is the difference between the highest and the second highest Rent(as % of GDP) of Belize?
Your answer should be compact. 0.43. What is the difference between the highest and the second highest Rent(as % of GDP) of Georgia?
Your response must be concise. 0. What is the difference between the highest and the second highest Rent(as % of GDP) of Russian Federation?
Ensure brevity in your answer.  1.23. What is the difference between the highest and the lowest Rent(as % of GDP) in Middle East & North Africa (developing only)?
Offer a terse response. 13.19. What is the difference between the highest and the lowest Rent(as % of GDP) in Belize?
Offer a very short reply. 3.17. What is the difference between the highest and the lowest Rent(as % of GDP) of Georgia?
Give a very brief answer. 0.09. What is the difference between the highest and the lowest Rent(as % of GDP) of Russian Federation?
Your answer should be very brief. 4.41. 